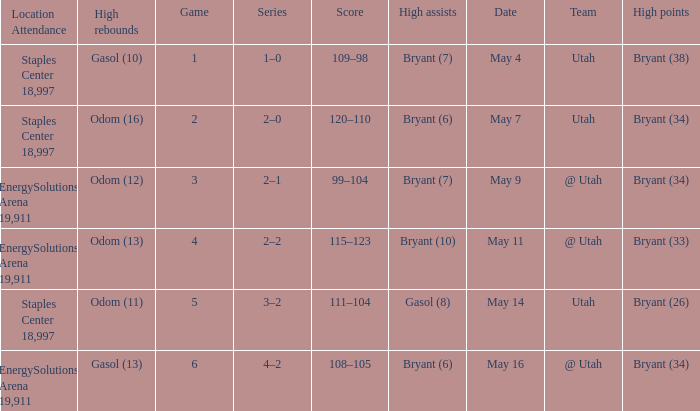What is the High rebounds with a Series with 4–2? Gasol (13). 